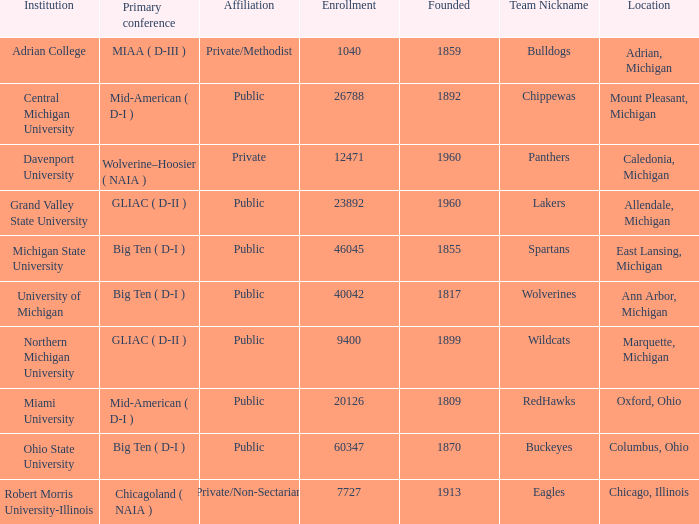Where is Robert Morris University-Illinois held? Chicago, Illinois. 